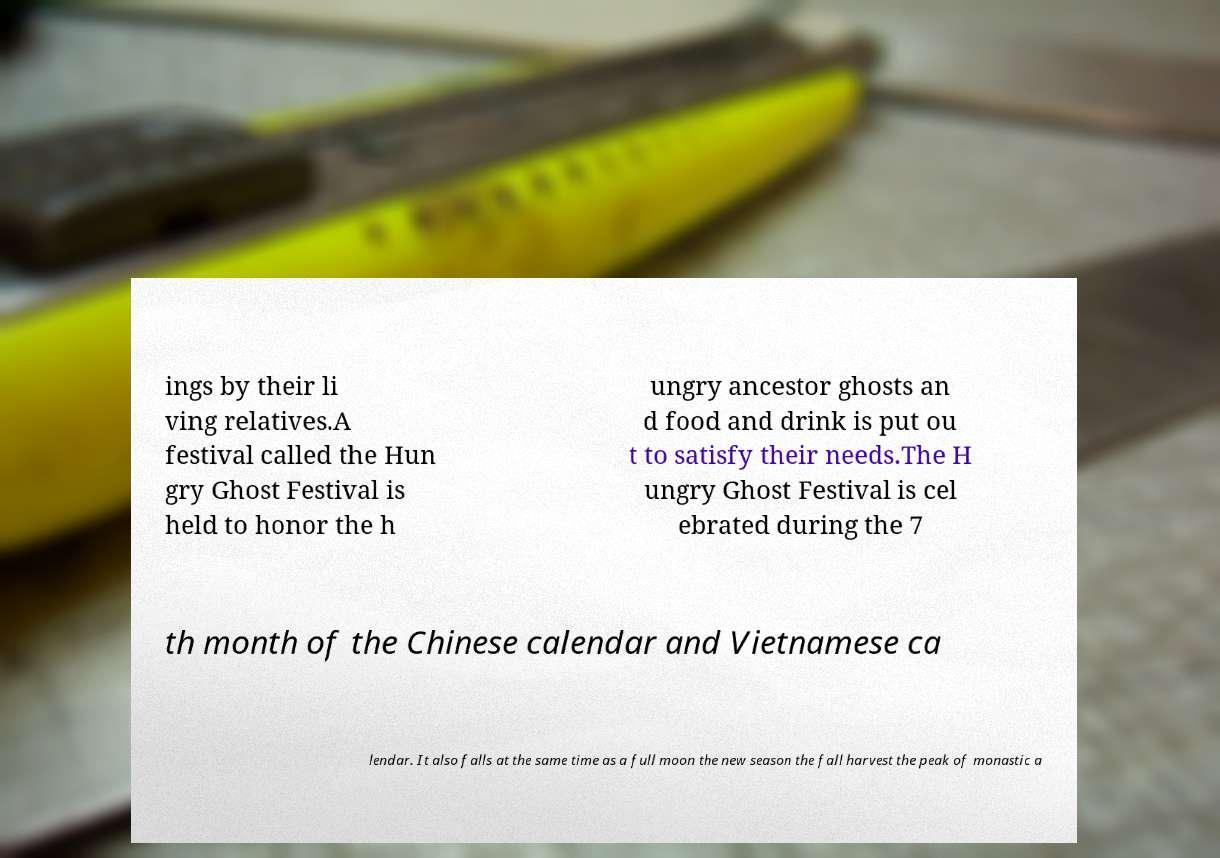Please identify and transcribe the text found in this image. ings by their li ving relatives.A festival called the Hun gry Ghost Festival is held to honor the h ungry ancestor ghosts an d food and drink is put ou t to satisfy their needs.The H ungry Ghost Festival is cel ebrated during the 7 th month of the Chinese calendar and Vietnamese ca lendar. It also falls at the same time as a full moon the new season the fall harvest the peak of monastic a 